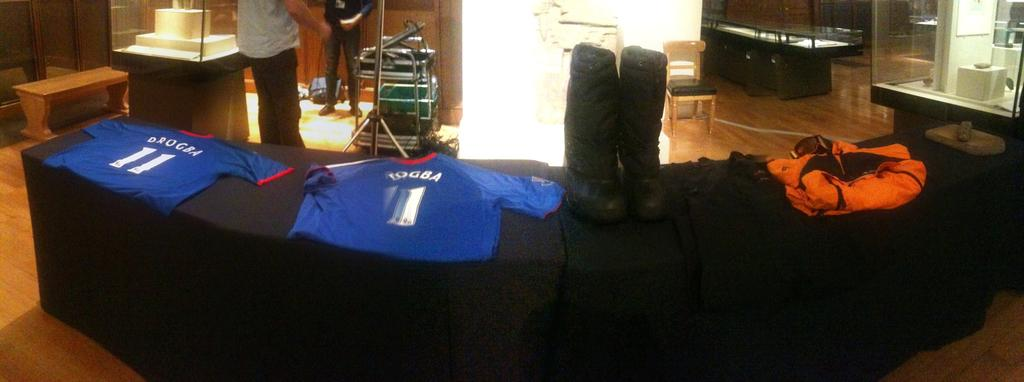Provide a one-sentence caption for the provided image. a display of clothing with a shirt saying DBOGEA 11 on it. 